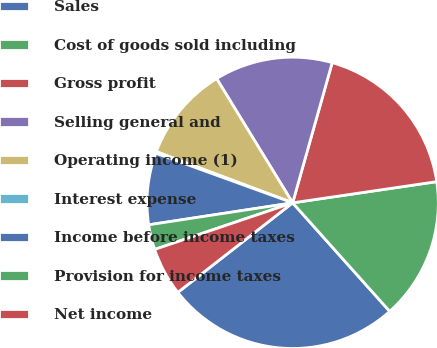<chart> <loc_0><loc_0><loc_500><loc_500><pie_chart><fcel>Sales<fcel>Cost of goods sold including<fcel>Gross profit<fcel>Selling general and<fcel>Operating income (1)<fcel>Interest expense<fcel>Income before income taxes<fcel>Provision for income taxes<fcel>Net income<nl><fcel>26.07%<fcel>15.71%<fcel>18.3%<fcel>13.12%<fcel>10.54%<fcel>0.18%<fcel>7.95%<fcel>2.77%<fcel>5.36%<nl></chart> 